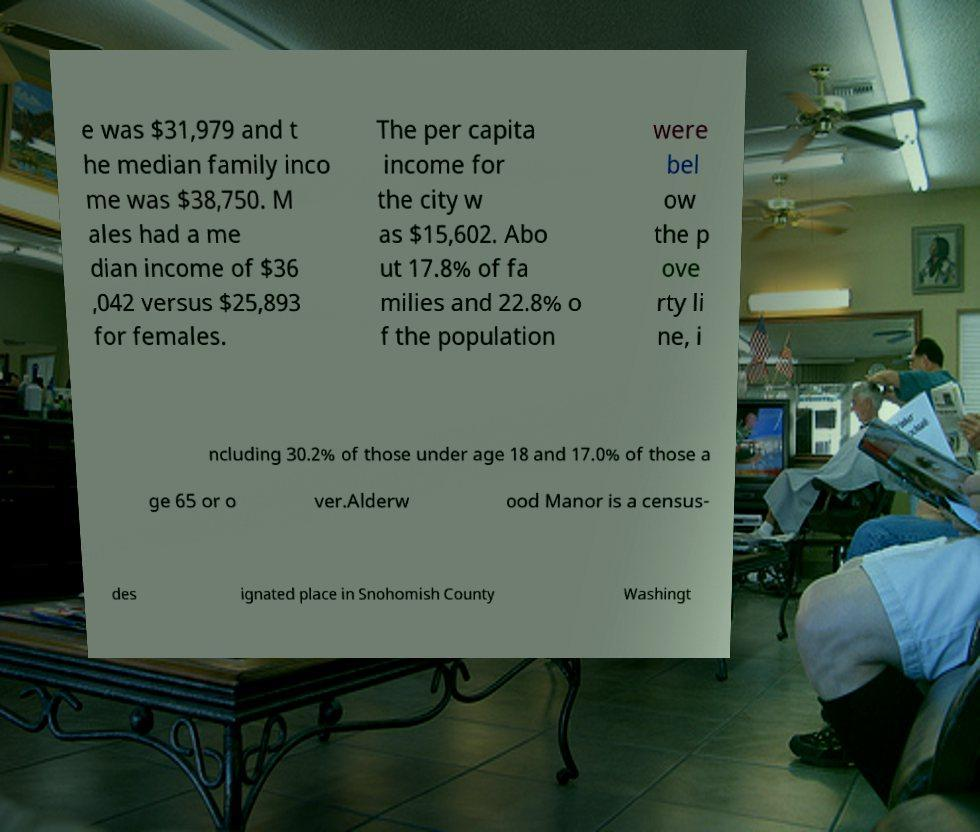Could you extract and type out the text from this image? e was $31,979 and t he median family inco me was $38,750. M ales had a me dian income of $36 ,042 versus $25,893 for females. The per capita income for the city w as $15,602. Abo ut 17.8% of fa milies and 22.8% o f the population were bel ow the p ove rty li ne, i ncluding 30.2% of those under age 18 and 17.0% of those a ge 65 or o ver.Alderw ood Manor is a census- des ignated place in Snohomish County Washingt 